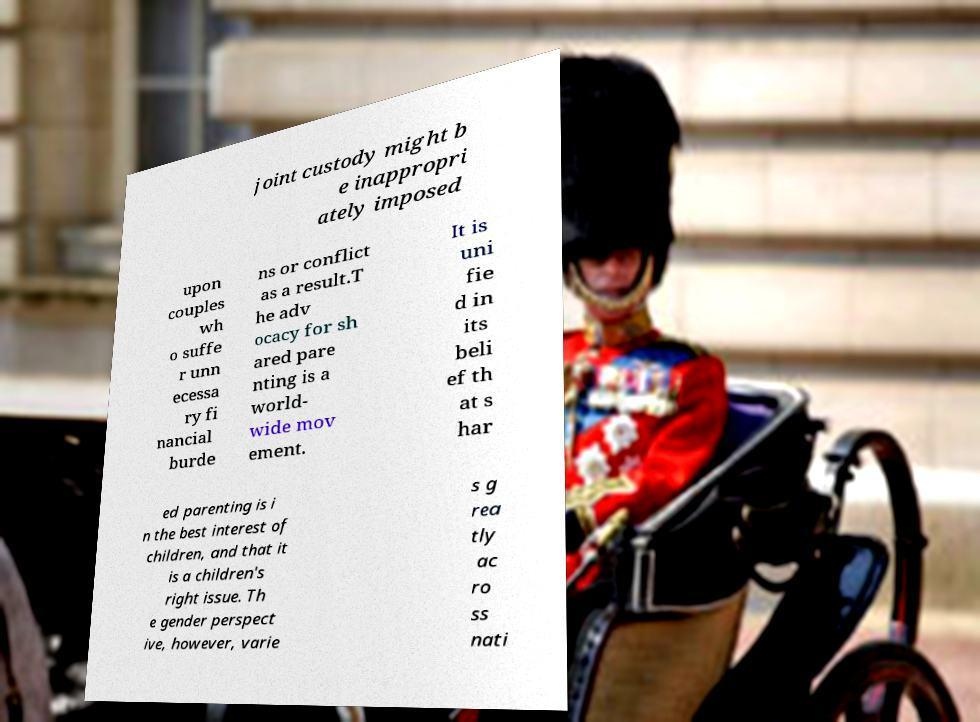Can you accurately transcribe the text from the provided image for me? joint custody might b e inappropri ately imposed upon couples wh o suffe r unn ecessa ry fi nancial burde ns or conflict as a result.T he adv ocacy for sh ared pare nting is a world- wide mov ement. It is uni fie d in its beli ef th at s har ed parenting is i n the best interest of children, and that it is a children's right issue. Th e gender perspect ive, however, varie s g rea tly ac ro ss nati 